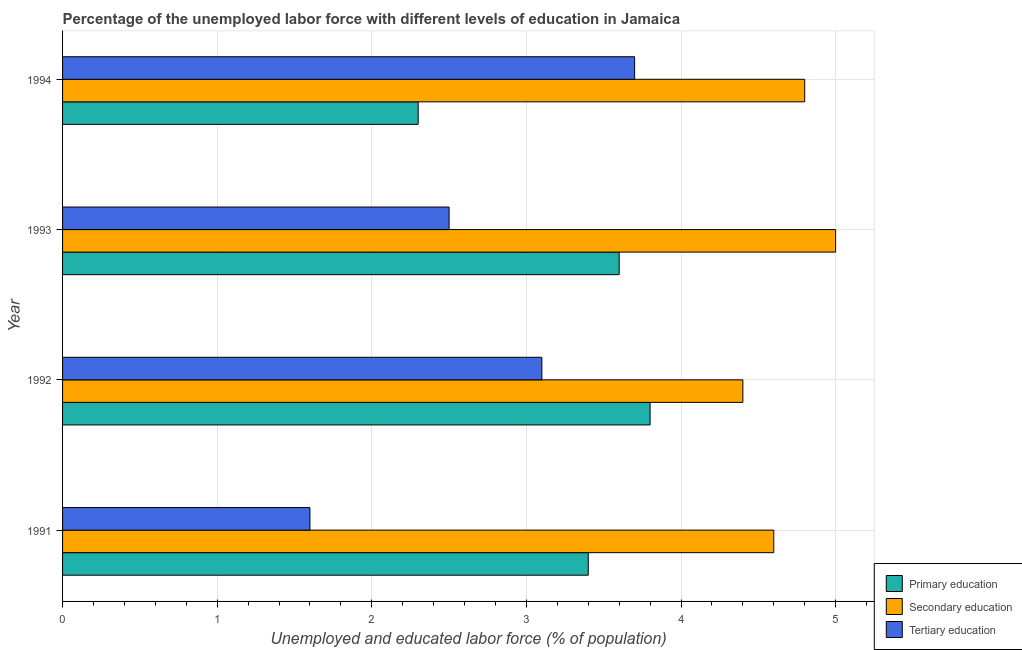How many different coloured bars are there?
Your response must be concise. 3. How many groups of bars are there?
Make the answer very short. 4. Are the number of bars per tick equal to the number of legend labels?
Keep it short and to the point. Yes. How many bars are there on the 4th tick from the top?
Keep it short and to the point. 3. How many bars are there on the 4th tick from the bottom?
Provide a succinct answer. 3. What is the label of the 2nd group of bars from the top?
Offer a terse response. 1993. In how many cases, is the number of bars for a given year not equal to the number of legend labels?
Your answer should be compact. 0. What is the percentage of labor force who received tertiary education in 1992?
Offer a terse response. 3.1. Across all years, what is the maximum percentage of labor force who received tertiary education?
Offer a very short reply. 3.7. Across all years, what is the minimum percentage of labor force who received tertiary education?
Offer a terse response. 1.6. In which year was the percentage of labor force who received primary education maximum?
Make the answer very short. 1992. In which year was the percentage of labor force who received secondary education minimum?
Offer a very short reply. 1992. What is the total percentage of labor force who received secondary education in the graph?
Offer a terse response. 18.8. What is the difference between the percentage of labor force who received secondary education in 1991 and the percentage of labor force who received tertiary education in 1994?
Your answer should be very brief. 0.9. In the year 1994, what is the difference between the percentage of labor force who received secondary education and percentage of labor force who received primary education?
Your response must be concise. 2.5. What is the ratio of the percentage of labor force who received primary education in 1991 to that in 1993?
Offer a very short reply. 0.94. What is the difference between the highest and the lowest percentage of labor force who received secondary education?
Give a very brief answer. 0.6. What does the 1st bar from the top in 1991 represents?
Your answer should be compact. Tertiary education. What does the 2nd bar from the bottom in 1992 represents?
Offer a very short reply. Secondary education. Is it the case that in every year, the sum of the percentage of labor force who received primary education and percentage of labor force who received secondary education is greater than the percentage of labor force who received tertiary education?
Offer a very short reply. Yes. How many bars are there?
Give a very brief answer. 12. Are all the bars in the graph horizontal?
Make the answer very short. Yes. What is the difference between two consecutive major ticks on the X-axis?
Provide a succinct answer. 1. Does the graph contain grids?
Your response must be concise. Yes. How many legend labels are there?
Keep it short and to the point. 3. How are the legend labels stacked?
Your answer should be very brief. Vertical. What is the title of the graph?
Make the answer very short. Percentage of the unemployed labor force with different levels of education in Jamaica. Does "Solid fuel" appear as one of the legend labels in the graph?
Give a very brief answer. No. What is the label or title of the X-axis?
Ensure brevity in your answer.  Unemployed and educated labor force (% of population). What is the Unemployed and educated labor force (% of population) of Primary education in 1991?
Offer a terse response. 3.4. What is the Unemployed and educated labor force (% of population) of Secondary education in 1991?
Offer a terse response. 4.6. What is the Unemployed and educated labor force (% of population) of Tertiary education in 1991?
Make the answer very short. 1.6. What is the Unemployed and educated labor force (% of population) in Primary education in 1992?
Make the answer very short. 3.8. What is the Unemployed and educated labor force (% of population) of Secondary education in 1992?
Give a very brief answer. 4.4. What is the Unemployed and educated labor force (% of population) in Tertiary education in 1992?
Offer a terse response. 3.1. What is the Unemployed and educated labor force (% of population) in Primary education in 1993?
Provide a short and direct response. 3.6. What is the Unemployed and educated labor force (% of population) in Secondary education in 1993?
Offer a terse response. 5. What is the Unemployed and educated labor force (% of population) of Primary education in 1994?
Offer a very short reply. 2.3. What is the Unemployed and educated labor force (% of population) in Secondary education in 1994?
Give a very brief answer. 4.8. What is the Unemployed and educated labor force (% of population) in Tertiary education in 1994?
Give a very brief answer. 3.7. Across all years, what is the maximum Unemployed and educated labor force (% of population) of Primary education?
Provide a short and direct response. 3.8. Across all years, what is the maximum Unemployed and educated labor force (% of population) of Tertiary education?
Your response must be concise. 3.7. Across all years, what is the minimum Unemployed and educated labor force (% of population) of Primary education?
Ensure brevity in your answer.  2.3. Across all years, what is the minimum Unemployed and educated labor force (% of population) in Secondary education?
Ensure brevity in your answer.  4.4. Across all years, what is the minimum Unemployed and educated labor force (% of population) of Tertiary education?
Keep it short and to the point. 1.6. What is the total Unemployed and educated labor force (% of population) of Primary education in the graph?
Your answer should be very brief. 13.1. What is the total Unemployed and educated labor force (% of population) in Tertiary education in the graph?
Provide a short and direct response. 10.9. What is the difference between the Unemployed and educated labor force (% of population) in Primary education in 1991 and that in 1992?
Make the answer very short. -0.4. What is the difference between the Unemployed and educated labor force (% of population) of Primary education in 1991 and that in 1993?
Your answer should be compact. -0.2. What is the difference between the Unemployed and educated labor force (% of population) of Secondary education in 1991 and that in 1993?
Offer a very short reply. -0.4. What is the difference between the Unemployed and educated labor force (% of population) in Primary education in 1991 and that in 1994?
Offer a terse response. 1.1. What is the difference between the Unemployed and educated labor force (% of population) of Secondary education in 1991 and that in 1994?
Offer a terse response. -0.2. What is the difference between the Unemployed and educated labor force (% of population) of Primary education in 1992 and that in 1993?
Your answer should be compact. 0.2. What is the difference between the Unemployed and educated labor force (% of population) in Secondary education in 1992 and that in 1993?
Offer a terse response. -0.6. What is the difference between the Unemployed and educated labor force (% of population) of Tertiary education in 1992 and that in 1993?
Provide a succinct answer. 0.6. What is the difference between the Unemployed and educated labor force (% of population) of Primary education in 1993 and that in 1994?
Provide a succinct answer. 1.3. What is the difference between the Unemployed and educated labor force (% of population) in Secondary education in 1993 and that in 1994?
Offer a terse response. 0.2. What is the difference between the Unemployed and educated labor force (% of population) in Tertiary education in 1993 and that in 1994?
Make the answer very short. -1.2. What is the difference between the Unemployed and educated labor force (% of population) in Primary education in 1991 and the Unemployed and educated labor force (% of population) in Secondary education in 1992?
Make the answer very short. -1. What is the difference between the Unemployed and educated labor force (% of population) in Primary education in 1991 and the Unemployed and educated labor force (% of population) in Secondary education in 1993?
Make the answer very short. -1.6. What is the difference between the Unemployed and educated labor force (% of population) in Primary education in 1991 and the Unemployed and educated labor force (% of population) in Tertiary education in 1993?
Your response must be concise. 0.9. What is the difference between the Unemployed and educated labor force (% of population) of Secondary education in 1991 and the Unemployed and educated labor force (% of population) of Tertiary education in 1994?
Provide a succinct answer. 0.9. What is the difference between the Unemployed and educated labor force (% of population) in Primary education in 1992 and the Unemployed and educated labor force (% of population) in Secondary education in 1993?
Provide a short and direct response. -1.2. What is the difference between the Unemployed and educated labor force (% of population) in Secondary education in 1992 and the Unemployed and educated labor force (% of population) in Tertiary education in 1993?
Keep it short and to the point. 1.9. What is the difference between the Unemployed and educated labor force (% of population) in Primary education in 1992 and the Unemployed and educated labor force (% of population) in Tertiary education in 1994?
Give a very brief answer. 0.1. What is the difference between the Unemployed and educated labor force (% of population) in Secondary education in 1992 and the Unemployed and educated labor force (% of population) in Tertiary education in 1994?
Provide a succinct answer. 0.7. What is the difference between the Unemployed and educated labor force (% of population) in Primary education in 1993 and the Unemployed and educated labor force (% of population) in Secondary education in 1994?
Keep it short and to the point. -1.2. What is the difference between the Unemployed and educated labor force (% of population) of Secondary education in 1993 and the Unemployed and educated labor force (% of population) of Tertiary education in 1994?
Offer a very short reply. 1.3. What is the average Unemployed and educated labor force (% of population) of Primary education per year?
Your answer should be very brief. 3.27. What is the average Unemployed and educated labor force (% of population) of Tertiary education per year?
Your answer should be compact. 2.73. In the year 1991, what is the difference between the Unemployed and educated labor force (% of population) in Primary education and Unemployed and educated labor force (% of population) in Tertiary education?
Your answer should be very brief. 1.8. In the year 1992, what is the difference between the Unemployed and educated labor force (% of population) in Primary education and Unemployed and educated labor force (% of population) in Tertiary education?
Your answer should be compact. 0.7. In the year 1993, what is the difference between the Unemployed and educated labor force (% of population) in Primary education and Unemployed and educated labor force (% of population) in Secondary education?
Give a very brief answer. -1.4. In the year 1994, what is the difference between the Unemployed and educated labor force (% of population) in Primary education and Unemployed and educated labor force (% of population) in Tertiary education?
Provide a succinct answer. -1.4. What is the ratio of the Unemployed and educated labor force (% of population) of Primary education in 1991 to that in 1992?
Your answer should be very brief. 0.89. What is the ratio of the Unemployed and educated labor force (% of population) in Secondary education in 1991 to that in 1992?
Offer a very short reply. 1.05. What is the ratio of the Unemployed and educated labor force (% of population) in Tertiary education in 1991 to that in 1992?
Ensure brevity in your answer.  0.52. What is the ratio of the Unemployed and educated labor force (% of population) of Primary education in 1991 to that in 1993?
Keep it short and to the point. 0.94. What is the ratio of the Unemployed and educated labor force (% of population) in Secondary education in 1991 to that in 1993?
Provide a succinct answer. 0.92. What is the ratio of the Unemployed and educated labor force (% of population) of Tertiary education in 1991 to that in 1993?
Provide a succinct answer. 0.64. What is the ratio of the Unemployed and educated labor force (% of population) of Primary education in 1991 to that in 1994?
Offer a terse response. 1.48. What is the ratio of the Unemployed and educated labor force (% of population) in Secondary education in 1991 to that in 1994?
Your answer should be compact. 0.96. What is the ratio of the Unemployed and educated labor force (% of population) of Tertiary education in 1991 to that in 1994?
Offer a very short reply. 0.43. What is the ratio of the Unemployed and educated labor force (% of population) of Primary education in 1992 to that in 1993?
Provide a short and direct response. 1.06. What is the ratio of the Unemployed and educated labor force (% of population) of Secondary education in 1992 to that in 1993?
Give a very brief answer. 0.88. What is the ratio of the Unemployed and educated labor force (% of population) in Tertiary education in 1992 to that in 1993?
Your answer should be compact. 1.24. What is the ratio of the Unemployed and educated labor force (% of population) in Primary education in 1992 to that in 1994?
Offer a terse response. 1.65. What is the ratio of the Unemployed and educated labor force (% of population) of Secondary education in 1992 to that in 1994?
Ensure brevity in your answer.  0.92. What is the ratio of the Unemployed and educated labor force (% of population) in Tertiary education in 1992 to that in 1994?
Keep it short and to the point. 0.84. What is the ratio of the Unemployed and educated labor force (% of population) in Primary education in 1993 to that in 1994?
Make the answer very short. 1.57. What is the ratio of the Unemployed and educated labor force (% of population) in Secondary education in 1993 to that in 1994?
Offer a terse response. 1.04. What is the ratio of the Unemployed and educated labor force (% of population) of Tertiary education in 1993 to that in 1994?
Offer a very short reply. 0.68. What is the difference between the highest and the lowest Unemployed and educated labor force (% of population) of Primary education?
Provide a succinct answer. 1.5. What is the difference between the highest and the lowest Unemployed and educated labor force (% of population) of Secondary education?
Keep it short and to the point. 0.6. 